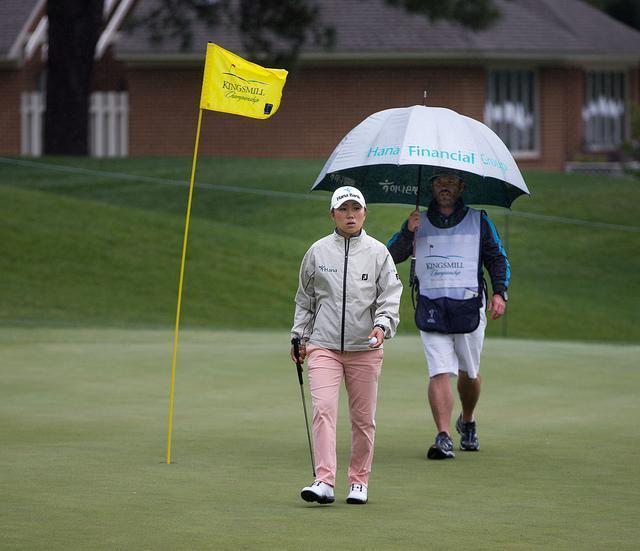How many people are in the picture?
Give a very brief answer. 2. How many human statues are to the left of the clock face?
Give a very brief answer. 0. 